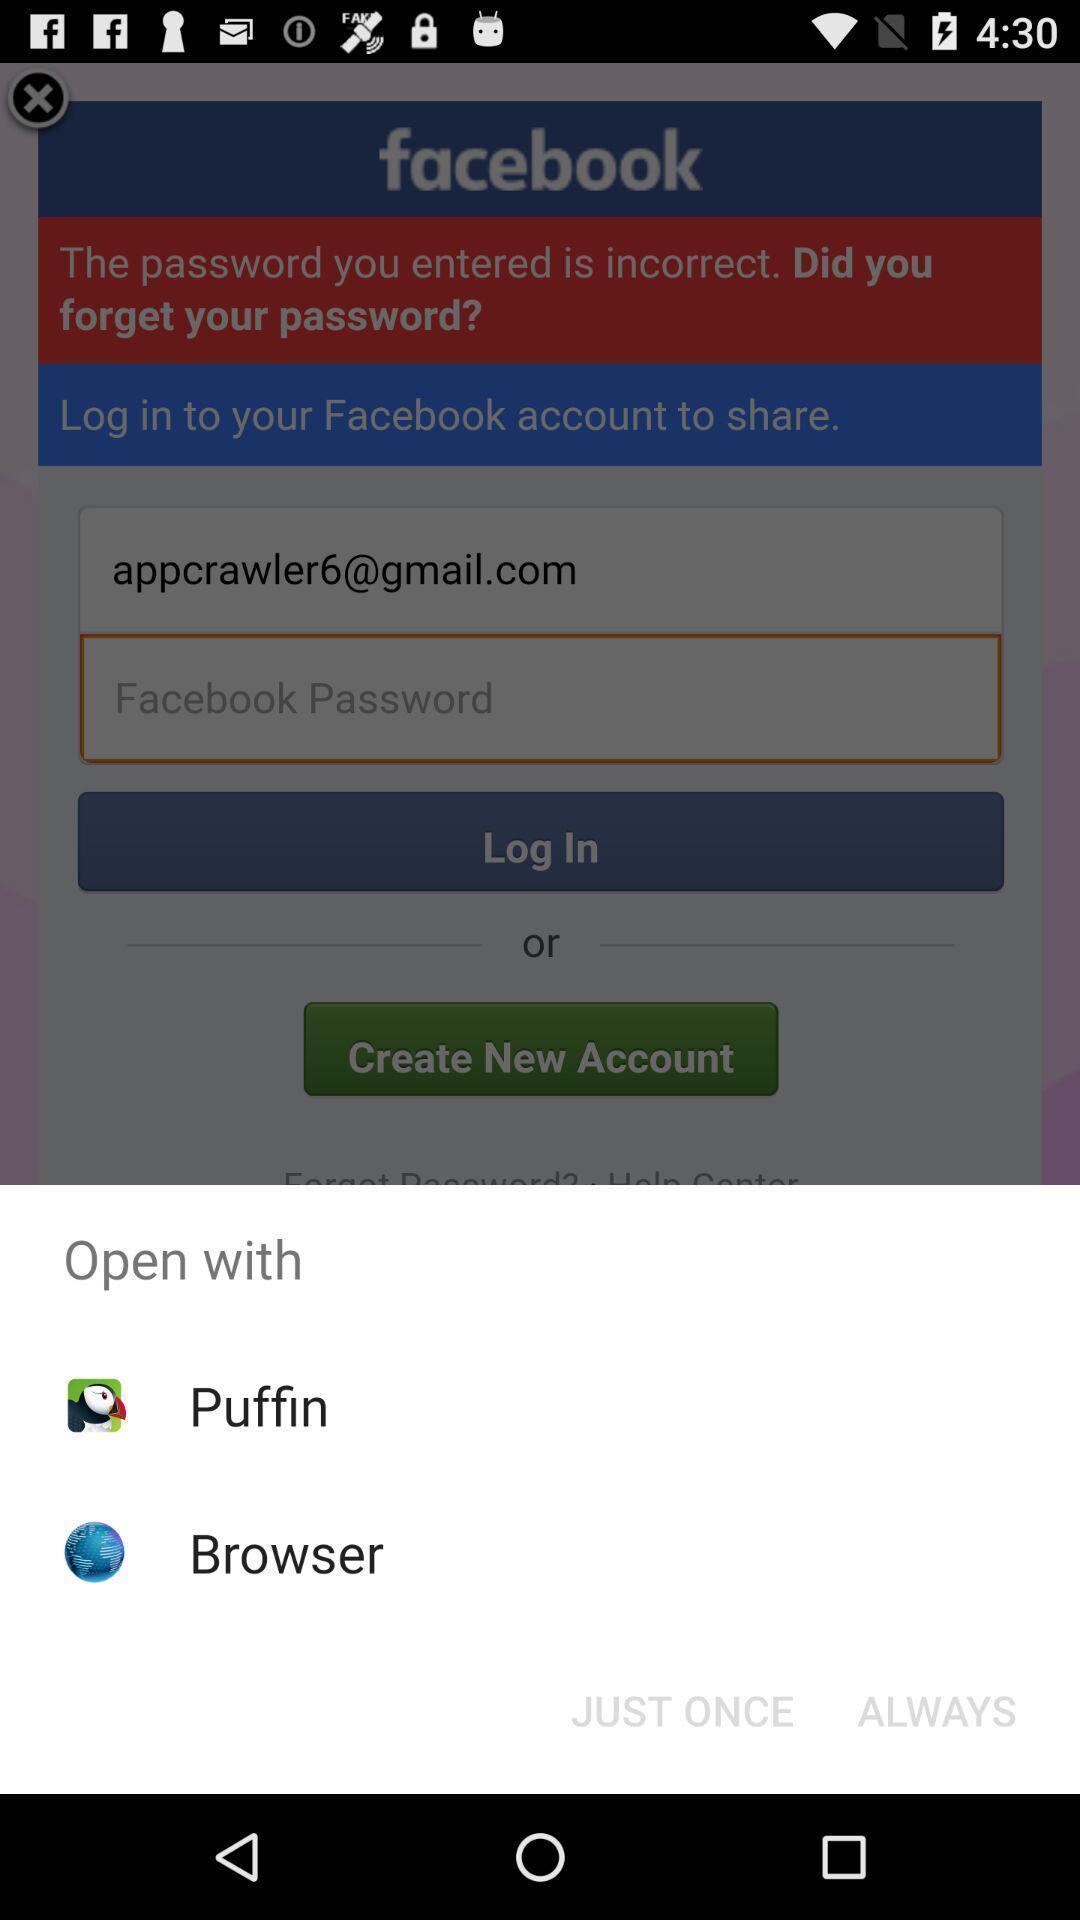Explain what's happening in this screen capture. Pop-up to open an application with multiple options. 